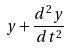<formula> <loc_0><loc_0><loc_500><loc_500>y + \frac { d ^ { 2 } y } { d t ^ { 2 } }</formula> 